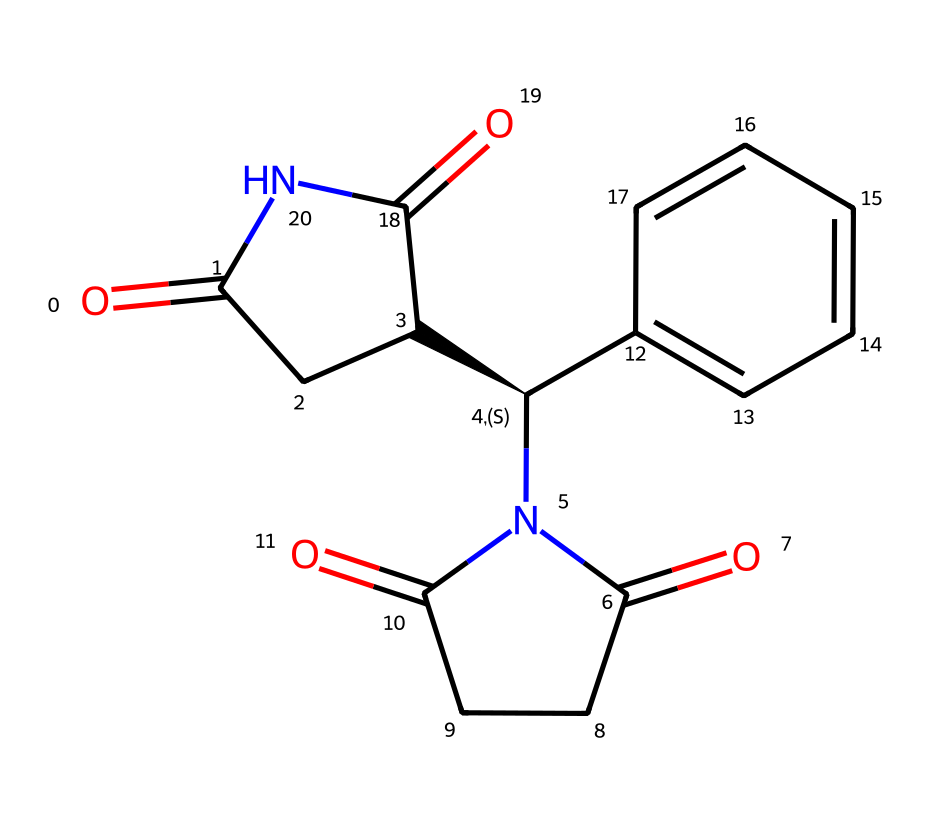What is the molecular formula of thalidomide? To determine the molecular formula, we analyze the chemical structure from the SMILES representation. The compounds in the structure consist of carbon (C), hydrogen (H), nitrogen (N), and oxygen (O). Counting the atoms gives C13, H10, N2, O4. Thus, the molecular formula is C13H10N2O4.
Answer: C13H10N2O4 How many chiral centers are present in thalidomide? By examining the structure, we can identify any chiral centers. A chiral center is usually a carbon atom connected to four different substituents. Upon analysis of the structure, there is one carbon (marked with a chiral center "@") that meets this criterion. Therefore, thalidomide has one chiral center.
Answer: 1 What type of compound is thalidomide categorized as? Thalidomide is primarily recognized as a pharmaceutical drug. Analyzing its structure reveals that it contains both amide and ketone functional groups, but in the context of its application and classification, it is best categorized as a drug compound.
Answer: drug What distinct configurations can the chiral center of thalidomide adopt? Chiral compounds typically have two possible configurations (R and S). The configuration at the chiral center of thalidomide can therefore adopt either an R (rectus) or S (sinister) configuration due to the differentiating groups attached to the chiral carbon. These configurations are important for the compound's biological activity.
Answer: R and S How many rings are present in the thalidomide structure? Upon inspecting the structure, we see rings formed by connected carbon atoms. Specifically, thalidomide includes two distinct ring structures known as a cyclic moiety. Counting these rings provides us with the total number.
Answer: 2 What is the significance of thalidomide's chirality in its pharmacological effects? The chirality of thalidomide is significant because only one of its enantiomers (the R or S configuration) exerts the desired therapeutic effects, while the other can cause harmful side effects, playing a crucial role in the drug's safety and efficacy. This highlights the importance of understanding chiral compounds in drug development.
Answer: therapeutic effects 